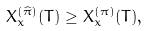<formula> <loc_0><loc_0><loc_500><loc_500>X _ { x } ^ { ( \widehat { \pi } ) } ( T ) \geq X _ { x } ^ { ( \pi ) } ( T ) , \text { }</formula> 